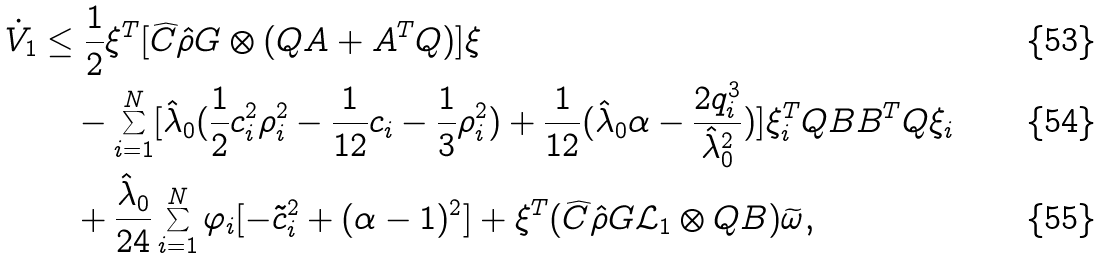<formula> <loc_0><loc_0><loc_500><loc_500>\dot { V } _ { 1 } & \leq \frac { 1 } { 2 } \xi ^ { T } [ \widehat { C } \hat { \rho } G \otimes ( Q A + A ^ { T } Q ) ] \xi \\ & \quad - \sum _ { i = 1 } ^ { N } [ \hat { \lambda } _ { 0 } ( \frac { 1 } { 2 } c _ { i } ^ { 2 } \rho _ { i } ^ { 2 } - \frac { 1 } { 1 2 } c _ { i } - \frac { 1 } { 3 } \rho _ { i } ^ { 2 } ) + \frac { 1 } { 1 2 } ( \hat { \lambda } _ { 0 } \alpha - \frac { 2 q _ { i } ^ { 3 } } { \hat { \lambda } _ { 0 } ^ { 2 } } ) ] \xi ^ { T } _ { i } Q B B ^ { T } Q \xi _ { i } \\ & \quad + \frac { \hat { \lambda } _ { 0 } } { 2 4 } \sum _ { i = 1 } ^ { N } \varphi _ { i } [ - \tilde { c } _ { i } ^ { 2 } + ( \alpha - 1 ) ^ { 2 } ] + \xi ^ { T } ( \widehat { C } \hat { \rho } G \mathcal { L } _ { 1 } \otimes Q B ) \widetilde { \omega } ,</formula> 